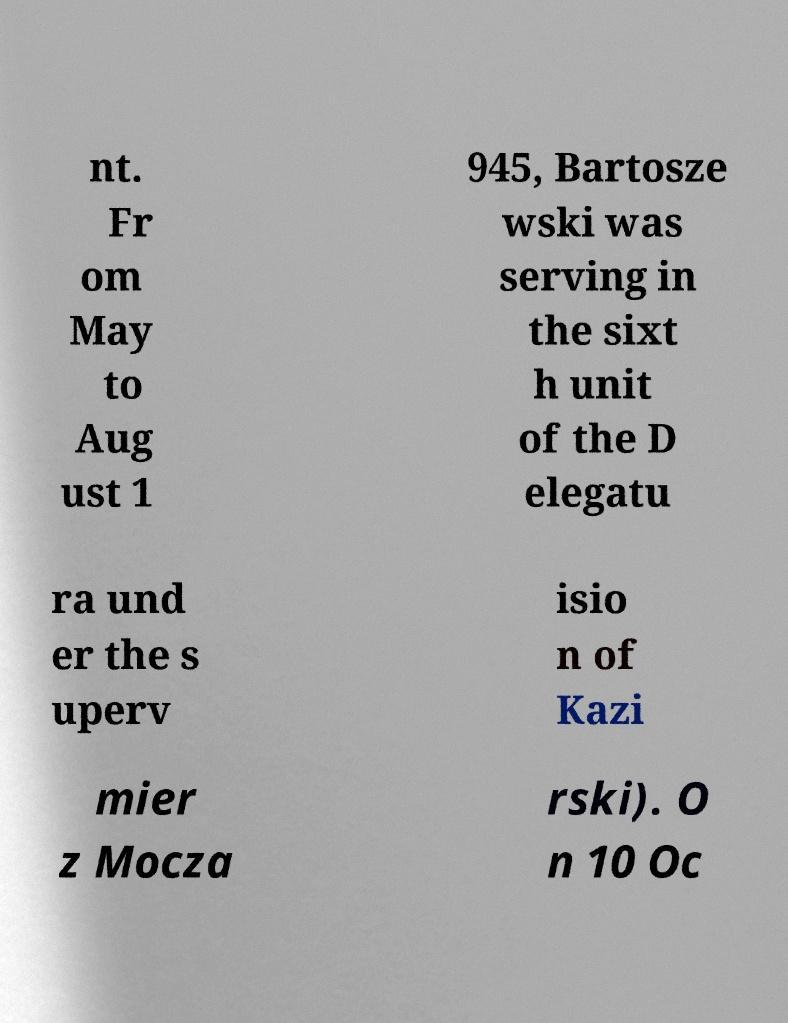What messages or text are displayed in this image? I need them in a readable, typed format. nt. Fr om May to Aug ust 1 945, Bartosze wski was serving in the sixt h unit of the D elegatu ra und er the s uperv isio n of Kazi mier z Mocza rski). O n 10 Oc 